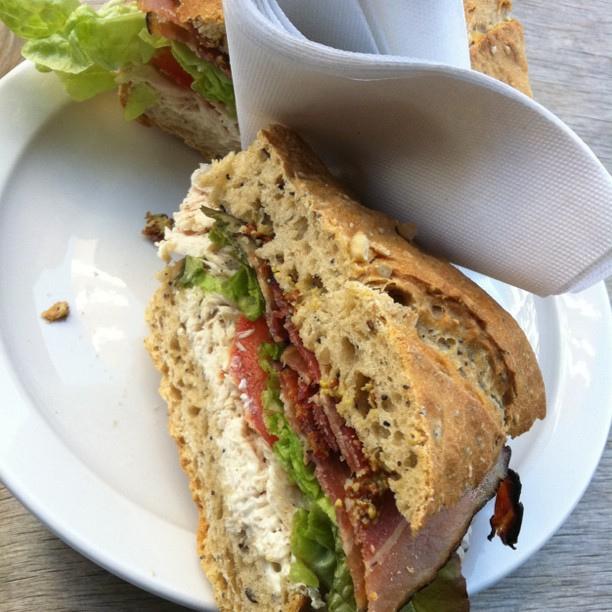How many types of meat are on the sandwich?
Give a very brief answer. 2. What is the red vegetable under the lettuce?
Give a very brief answer. Tomato. What does this sandwich taste like?
Be succinct. Delicious. 